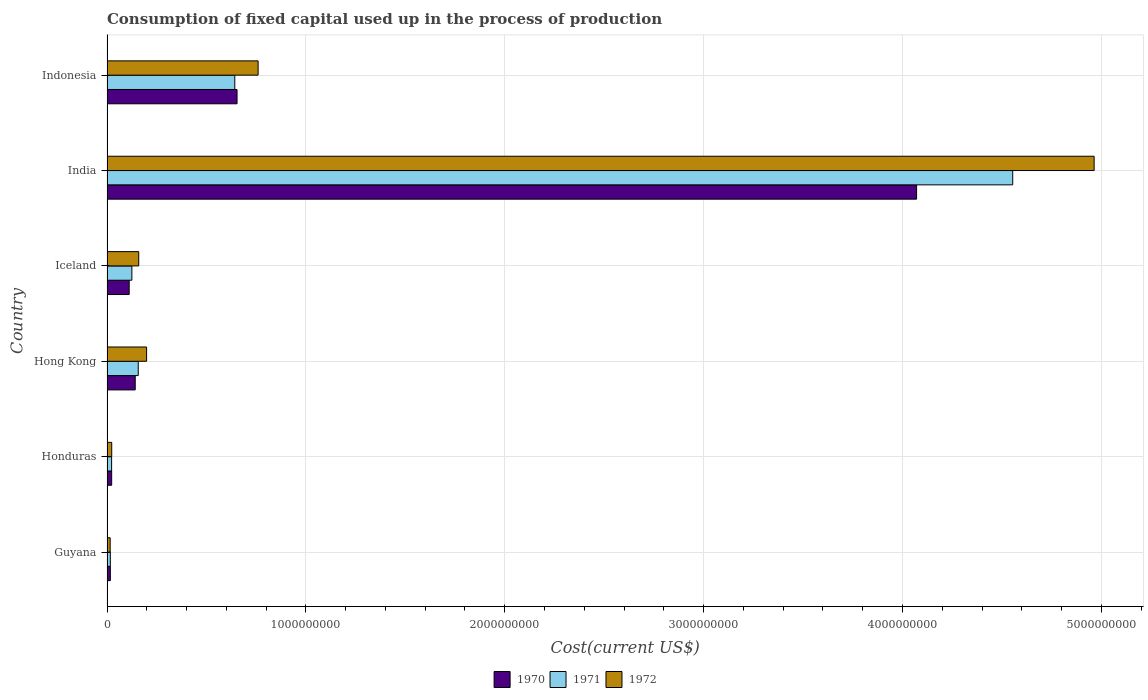How many different coloured bars are there?
Make the answer very short. 3. How many groups of bars are there?
Offer a terse response. 6. Are the number of bars per tick equal to the number of legend labels?
Your answer should be very brief. Yes. How many bars are there on the 2nd tick from the top?
Keep it short and to the point. 3. How many bars are there on the 5th tick from the bottom?
Provide a succinct answer. 3. What is the label of the 6th group of bars from the top?
Make the answer very short. Guyana. What is the amount consumed in the process of production in 1970 in Iceland?
Your response must be concise. 1.12e+08. Across all countries, what is the maximum amount consumed in the process of production in 1970?
Provide a succinct answer. 4.07e+09. Across all countries, what is the minimum amount consumed in the process of production in 1971?
Offer a terse response. 1.67e+07. In which country was the amount consumed in the process of production in 1972 minimum?
Offer a terse response. Guyana. What is the total amount consumed in the process of production in 1972 in the graph?
Give a very brief answer. 6.12e+09. What is the difference between the amount consumed in the process of production in 1972 in Hong Kong and that in Indonesia?
Make the answer very short. -5.61e+08. What is the difference between the amount consumed in the process of production in 1970 in Honduras and the amount consumed in the process of production in 1971 in Indonesia?
Keep it short and to the point. -6.19e+08. What is the average amount consumed in the process of production in 1971 per country?
Make the answer very short. 9.20e+08. What is the difference between the amount consumed in the process of production in 1970 and amount consumed in the process of production in 1972 in Honduras?
Offer a terse response. -2.98e+05. What is the ratio of the amount consumed in the process of production in 1972 in Hong Kong to that in Indonesia?
Offer a terse response. 0.26. Is the amount consumed in the process of production in 1970 in Guyana less than that in Hong Kong?
Keep it short and to the point. Yes. What is the difference between the highest and the second highest amount consumed in the process of production in 1970?
Keep it short and to the point. 3.42e+09. What is the difference between the highest and the lowest amount consumed in the process of production in 1972?
Ensure brevity in your answer.  4.95e+09. What does the 3rd bar from the top in Indonesia represents?
Your answer should be very brief. 1970. What does the 1st bar from the bottom in India represents?
Your response must be concise. 1970. How many bars are there?
Your response must be concise. 18. Are all the bars in the graph horizontal?
Offer a very short reply. Yes. What is the difference between two consecutive major ticks on the X-axis?
Your answer should be compact. 1.00e+09. Does the graph contain any zero values?
Offer a terse response. No. Does the graph contain grids?
Offer a very short reply. Yes. How many legend labels are there?
Make the answer very short. 3. How are the legend labels stacked?
Offer a very short reply. Horizontal. What is the title of the graph?
Keep it short and to the point. Consumption of fixed capital used up in the process of production. Does "1960" appear as one of the legend labels in the graph?
Keep it short and to the point. No. What is the label or title of the X-axis?
Provide a succinct answer. Cost(current US$). What is the label or title of the Y-axis?
Keep it short and to the point. Country. What is the Cost(current US$) in 1970 in Guyana?
Offer a terse response. 1.69e+07. What is the Cost(current US$) of 1971 in Guyana?
Provide a short and direct response. 1.67e+07. What is the Cost(current US$) in 1972 in Guyana?
Offer a very short reply. 1.59e+07. What is the Cost(current US$) of 1970 in Honduras?
Offer a very short reply. 2.34e+07. What is the Cost(current US$) in 1971 in Honduras?
Keep it short and to the point. 2.32e+07. What is the Cost(current US$) of 1972 in Honduras?
Give a very brief answer. 2.37e+07. What is the Cost(current US$) in 1970 in Hong Kong?
Offer a terse response. 1.42e+08. What is the Cost(current US$) in 1971 in Hong Kong?
Provide a succinct answer. 1.57e+08. What is the Cost(current US$) of 1972 in Hong Kong?
Your answer should be compact. 1.99e+08. What is the Cost(current US$) of 1970 in Iceland?
Ensure brevity in your answer.  1.12e+08. What is the Cost(current US$) of 1971 in Iceland?
Offer a very short reply. 1.25e+08. What is the Cost(current US$) in 1972 in Iceland?
Ensure brevity in your answer.  1.60e+08. What is the Cost(current US$) in 1970 in India?
Offer a terse response. 4.07e+09. What is the Cost(current US$) of 1971 in India?
Offer a terse response. 4.55e+09. What is the Cost(current US$) of 1972 in India?
Give a very brief answer. 4.96e+09. What is the Cost(current US$) in 1970 in Indonesia?
Your response must be concise. 6.54e+08. What is the Cost(current US$) of 1971 in Indonesia?
Keep it short and to the point. 6.43e+08. What is the Cost(current US$) in 1972 in Indonesia?
Your answer should be compact. 7.60e+08. Across all countries, what is the maximum Cost(current US$) in 1970?
Provide a short and direct response. 4.07e+09. Across all countries, what is the maximum Cost(current US$) in 1971?
Keep it short and to the point. 4.55e+09. Across all countries, what is the maximum Cost(current US$) in 1972?
Make the answer very short. 4.96e+09. Across all countries, what is the minimum Cost(current US$) in 1970?
Give a very brief answer. 1.69e+07. Across all countries, what is the minimum Cost(current US$) of 1971?
Make the answer very short. 1.67e+07. Across all countries, what is the minimum Cost(current US$) of 1972?
Offer a very short reply. 1.59e+07. What is the total Cost(current US$) in 1970 in the graph?
Provide a short and direct response. 5.02e+09. What is the total Cost(current US$) of 1971 in the graph?
Make the answer very short. 5.52e+09. What is the total Cost(current US$) in 1972 in the graph?
Offer a very short reply. 6.12e+09. What is the difference between the Cost(current US$) in 1970 in Guyana and that in Honduras?
Provide a short and direct response. -6.54e+06. What is the difference between the Cost(current US$) of 1971 in Guyana and that in Honduras?
Ensure brevity in your answer.  -6.46e+06. What is the difference between the Cost(current US$) in 1972 in Guyana and that in Honduras?
Your answer should be very brief. -7.83e+06. What is the difference between the Cost(current US$) in 1970 in Guyana and that in Hong Kong?
Your response must be concise. -1.25e+08. What is the difference between the Cost(current US$) in 1971 in Guyana and that in Hong Kong?
Offer a terse response. -1.40e+08. What is the difference between the Cost(current US$) in 1972 in Guyana and that in Hong Kong?
Your answer should be compact. -1.83e+08. What is the difference between the Cost(current US$) in 1970 in Guyana and that in Iceland?
Make the answer very short. -9.46e+07. What is the difference between the Cost(current US$) of 1971 in Guyana and that in Iceland?
Your answer should be very brief. -1.08e+08. What is the difference between the Cost(current US$) of 1972 in Guyana and that in Iceland?
Make the answer very short. -1.44e+08. What is the difference between the Cost(current US$) in 1970 in Guyana and that in India?
Your answer should be compact. -4.05e+09. What is the difference between the Cost(current US$) in 1971 in Guyana and that in India?
Provide a succinct answer. -4.54e+09. What is the difference between the Cost(current US$) in 1972 in Guyana and that in India?
Your answer should be very brief. -4.95e+09. What is the difference between the Cost(current US$) of 1970 in Guyana and that in Indonesia?
Ensure brevity in your answer.  -6.37e+08. What is the difference between the Cost(current US$) of 1971 in Guyana and that in Indonesia?
Offer a terse response. -6.26e+08. What is the difference between the Cost(current US$) in 1972 in Guyana and that in Indonesia?
Your response must be concise. -7.44e+08. What is the difference between the Cost(current US$) of 1970 in Honduras and that in Hong Kong?
Make the answer very short. -1.18e+08. What is the difference between the Cost(current US$) of 1971 in Honduras and that in Hong Kong?
Make the answer very short. -1.34e+08. What is the difference between the Cost(current US$) of 1972 in Honduras and that in Hong Kong?
Provide a succinct answer. -1.75e+08. What is the difference between the Cost(current US$) in 1970 in Honduras and that in Iceland?
Offer a terse response. -8.81e+07. What is the difference between the Cost(current US$) in 1971 in Honduras and that in Iceland?
Ensure brevity in your answer.  -1.02e+08. What is the difference between the Cost(current US$) in 1972 in Honduras and that in Iceland?
Offer a terse response. -1.36e+08. What is the difference between the Cost(current US$) in 1970 in Honduras and that in India?
Offer a very short reply. -4.05e+09. What is the difference between the Cost(current US$) of 1971 in Honduras and that in India?
Your answer should be compact. -4.53e+09. What is the difference between the Cost(current US$) in 1972 in Honduras and that in India?
Offer a terse response. -4.94e+09. What is the difference between the Cost(current US$) of 1970 in Honduras and that in Indonesia?
Your response must be concise. -6.30e+08. What is the difference between the Cost(current US$) in 1971 in Honduras and that in Indonesia?
Your answer should be very brief. -6.19e+08. What is the difference between the Cost(current US$) of 1972 in Honduras and that in Indonesia?
Offer a terse response. -7.36e+08. What is the difference between the Cost(current US$) in 1970 in Hong Kong and that in Iceland?
Make the answer very short. 3.03e+07. What is the difference between the Cost(current US$) in 1971 in Hong Kong and that in Iceland?
Make the answer very short. 3.21e+07. What is the difference between the Cost(current US$) in 1972 in Hong Kong and that in Iceland?
Ensure brevity in your answer.  3.95e+07. What is the difference between the Cost(current US$) of 1970 in Hong Kong and that in India?
Provide a short and direct response. -3.93e+09. What is the difference between the Cost(current US$) in 1971 in Hong Kong and that in India?
Make the answer very short. -4.40e+09. What is the difference between the Cost(current US$) in 1972 in Hong Kong and that in India?
Provide a succinct answer. -4.76e+09. What is the difference between the Cost(current US$) in 1970 in Hong Kong and that in Indonesia?
Your response must be concise. -5.12e+08. What is the difference between the Cost(current US$) in 1971 in Hong Kong and that in Indonesia?
Keep it short and to the point. -4.86e+08. What is the difference between the Cost(current US$) of 1972 in Hong Kong and that in Indonesia?
Give a very brief answer. -5.61e+08. What is the difference between the Cost(current US$) in 1970 in Iceland and that in India?
Give a very brief answer. -3.96e+09. What is the difference between the Cost(current US$) in 1971 in Iceland and that in India?
Ensure brevity in your answer.  -4.43e+09. What is the difference between the Cost(current US$) in 1972 in Iceland and that in India?
Provide a succinct answer. -4.80e+09. What is the difference between the Cost(current US$) of 1970 in Iceland and that in Indonesia?
Ensure brevity in your answer.  -5.42e+08. What is the difference between the Cost(current US$) in 1971 in Iceland and that in Indonesia?
Your answer should be compact. -5.18e+08. What is the difference between the Cost(current US$) of 1972 in Iceland and that in Indonesia?
Offer a terse response. -6.00e+08. What is the difference between the Cost(current US$) in 1970 in India and that in Indonesia?
Make the answer very short. 3.42e+09. What is the difference between the Cost(current US$) in 1971 in India and that in Indonesia?
Offer a very short reply. 3.91e+09. What is the difference between the Cost(current US$) in 1972 in India and that in Indonesia?
Offer a terse response. 4.20e+09. What is the difference between the Cost(current US$) in 1970 in Guyana and the Cost(current US$) in 1971 in Honduras?
Offer a very short reply. -6.26e+06. What is the difference between the Cost(current US$) of 1970 in Guyana and the Cost(current US$) of 1972 in Honduras?
Offer a very short reply. -6.83e+06. What is the difference between the Cost(current US$) of 1971 in Guyana and the Cost(current US$) of 1972 in Honduras?
Your response must be concise. -7.03e+06. What is the difference between the Cost(current US$) of 1970 in Guyana and the Cost(current US$) of 1971 in Hong Kong?
Offer a terse response. -1.40e+08. What is the difference between the Cost(current US$) in 1970 in Guyana and the Cost(current US$) in 1972 in Hong Kong?
Your answer should be very brief. -1.82e+08. What is the difference between the Cost(current US$) in 1971 in Guyana and the Cost(current US$) in 1972 in Hong Kong?
Your response must be concise. -1.82e+08. What is the difference between the Cost(current US$) in 1970 in Guyana and the Cost(current US$) in 1971 in Iceland?
Your response must be concise. -1.08e+08. What is the difference between the Cost(current US$) of 1970 in Guyana and the Cost(current US$) of 1972 in Iceland?
Your answer should be very brief. -1.43e+08. What is the difference between the Cost(current US$) in 1971 in Guyana and the Cost(current US$) in 1972 in Iceland?
Provide a short and direct response. -1.43e+08. What is the difference between the Cost(current US$) in 1970 in Guyana and the Cost(current US$) in 1971 in India?
Keep it short and to the point. -4.54e+09. What is the difference between the Cost(current US$) of 1970 in Guyana and the Cost(current US$) of 1972 in India?
Make the answer very short. -4.95e+09. What is the difference between the Cost(current US$) of 1971 in Guyana and the Cost(current US$) of 1972 in India?
Keep it short and to the point. -4.95e+09. What is the difference between the Cost(current US$) in 1970 in Guyana and the Cost(current US$) in 1971 in Indonesia?
Your answer should be compact. -6.26e+08. What is the difference between the Cost(current US$) of 1970 in Guyana and the Cost(current US$) of 1972 in Indonesia?
Make the answer very short. -7.43e+08. What is the difference between the Cost(current US$) in 1971 in Guyana and the Cost(current US$) in 1972 in Indonesia?
Give a very brief answer. -7.43e+08. What is the difference between the Cost(current US$) of 1970 in Honduras and the Cost(current US$) of 1971 in Hong Kong?
Your answer should be compact. -1.34e+08. What is the difference between the Cost(current US$) in 1970 in Honduras and the Cost(current US$) in 1972 in Hong Kong?
Offer a terse response. -1.76e+08. What is the difference between the Cost(current US$) in 1971 in Honduras and the Cost(current US$) in 1972 in Hong Kong?
Your answer should be compact. -1.76e+08. What is the difference between the Cost(current US$) of 1970 in Honduras and the Cost(current US$) of 1971 in Iceland?
Provide a short and direct response. -1.02e+08. What is the difference between the Cost(current US$) in 1970 in Honduras and the Cost(current US$) in 1972 in Iceland?
Your answer should be compact. -1.36e+08. What is the difference between the Cost(current US$) in 1971 in Honduras and the Cost(current US$) in 1972 in Iceland?
Ensure brevity in your answer.  -1.36e+08. What is the difference between the Cost(current US$) of 1970 in Honduras and the Cost(current US$) of 1971 in India?
Your answer should be very brief. -4.53e+09. What is the difference between the Cost(current US$) of 1970 in Honduras and the Cost(current US$) of 1972 in India?
Your answer should be compact. -4.94e+09. What is the difference between the Cost(current US$) in 1971 in Honduras and the Cost(current US$) in 1972 in India?
Provide a succinct answer. -4.94e+09. What is the difference between the Cost(current US$) of 1970 in Honduras and the Cost(current US$) of 1971 in Indonesia?
Your answer should be very brief. -6.19e+08. What is the difference between the Cost(current US$) in 1970 in Honduras and the Cost(current US$) in 1972 in Indonesia?
Give a very brief answer. -7.36e+08. What is the difference between the Cost(current US$) of 1971 in Honduras and the Cost(current US$) of 1972 in Indonesia?
Provide a short and direct response. -7.37e+08. What is the difference between the Cost(current US$) of 1970 in Hong Kong and the Cost(current US$) of 1971 in Iceland?
Your response must be concise. 1.69e+07. What is the difference between the Cost(current US$) in 1970 in Hong Kong and the Cost(current US$) in 1972 in Iceland?
Offer a terse response. -1.77e+07. What is the difference between the Cost(current US$) in 1971 in Hong Kong and the Cost(current US$) in 1972 in Iceland?
Provide a short and direct response. -2.45e+06. What is the difference between the Cost(current US$) in 1970 in Hong Kong and the Cost(current US$) in 1971 in India?
Provide a succinct answer. -4.41e+09. What is the difference between the Cost(current US$) in 1970 in Hong Kong and the Cost(current US$) in 1972 in India?
Your response must be concise. -4.82e+09. What is the difference between the Cost(current US$) in 1971 in Hong Kong and the Cost(current US$) in 1972 in India?
Ensure brevity in your answer.  -4.81e+09. What is the difference between the Cost(current US$) in 1970 in Hong Kong and the Cost(current US$) in 1971 in Indonesia?
Provide a succinct answer. -5.01e+08. What is the difference between the Cost(current US$) in 1970 in Hong Kong and the Cost(current US$) in 1972 in Indonesia?
Your answer should be very brief. -6.18e+08. What is the difference between the Cost(current US$) in 1971 in Hong Kong and the Cost(current US$) in 1972 in Indonesia?
Your response must be concise. -6.03e+08. What is the difference between the Cost(current US$) in 1970 in Iceland and the Cost(current US$) in 1971 in India?
Offer a very short reply. -4.44e+09. What is the difference between the Cost(current US$) in 1970 in Iceland and the Cost(current US$) in 1972 in India?
Keep it short and to the point. -4.85e+09. What is the difference between the Cost(current US$) in 1971 in Iceland and the Cost(current US$) in 1972 in India?
Your response must be concise. -4.84e+09. What is the difference between the Cost(current US$) of 1970 in Iceland and the Cost(current US$) of 1971 in Indonesia?
Keep it short and to the point. -5.31e+08. What is the difference between the Cost(current US$) in 1970 in Iceland and the Cost(current US$) in 1972 in Indonesia?
Keep it short and to the point. -6.48e+08. What is the difference between the Cost(current US$) of 1971 in Iceland and the Cost(current US$) of 1972 in Indonesia?
Ensure brevity in your answer.  -6.35e+08. What is the difference between the Cost(current US$) in 1970 in India and the Cost(current US$) in 1971 in Indonesia?
Provide a short and direct response. 3.43e+09. What is the difference between the Cost(current US$) in 1970 in India and the Cost(current US$) in 1972 in Indonesia?
Ensure brevity in your answer.  3.31e+09. What is the difference between the Cost(current US$) in 1971 in India and the Cost(current US$) in 1972 in Indonesia?
Offer a very short reply. 3.79e+09. What is the average Cost(current US$) of 1970 per country?
Give a very brief answer. 8.36e+08. What is the average Cost(current US$) in 1971 per country?
Keep it short and to the point. 9.20e+08. What is the average Cost(current US$) of 1972 per country?
Offer a very short reply. 1.02e+09. What is the difference between the Cost(current US$) in 1970 and Cost(current US$) in 1972 in Guyana?
Your response must be concise. 9.95e+05. What is the difference between the Cost(current US$) in 1971 and Cost(current US$) in 1972 in Guyana?
Offer a very short reply. 7.95e+05. What is the difference between the Cost(current US$) in 1970 and Cost(current US$) in 1971 in Honduras?
Give a very brief answer. 2.75e+05. What is the difference between the Cost(current US$) of 1970 and Cost(current US$) of 1972 in Honduras?
Your answer should be compact. -2.98e+05. What is the difference between the Cost(current US$) of 1971 and Cost(current US$) of 1972 in Honduras?
Give a very brief answer. -5.73e+05. What is the difference between the Cost(current US$) of 1970 and Cost(current US$) of 1971 in Hong Kong?
Keep it short and to the point. -1.52e+07. What is the difference between the Cost(current US$) of 1970 and Cost(current US$) of 1972 in Hong Kong?
Your answer should be compact. -5.72e+07. What is the difference between the Cost(current US$) of 1971 and Cost(current US$) of 1972 in Hong Kong?
Make the answer very short. -4.20e+07. What is the difference between the Cost(current US$) of 1970 and Cost(current US$) of 1971 in Iceland?
Provide a succinct answer. -1.34e+07. What is the difference between the Cost(current US$) of 1970 and Cost(current US$) of 1972 in Iceland?
Offer a terse response. -4.80e+07. What is the difference between the Cost(current US$) in 1971 and Cost(current US$) in 1972 in Iceland?
Your answer should be compact. -3.46e+07. What is the difference between the Cost(current US$) in 1970 and Cost(current US$) in 1971 in India?
Your response must be concise. -4.83e+08. What is the difference between the Cost(current US$) in 1970 and Cost(current US$) in 1972 in India?
Give a very brief answer. -8.93e+08. What is the difference between the Cost(current US$) of 1971 and Cost(current US$) of 1972 in India?
Give a very brief answer. -4.09e+08. What is the difference between the Cost(current US$) in 1970 and Cost(current US$) in 1971 in Indonesia?
Your answer should be compact. 1.13e+07. What is the difference between the Cost(current US$) of 1970 and Cost(current US$) of 1972 in Indonesia?
Your response must be concise. -1.06e+08. What is the difference between the Cost(current US$) in 1971 and Cost(current US$) in 1972 in Indonesia?
Make the answer very short. -1.17e+08. What is the ratio of the Cost(current US$) in 1970 in Guyana to that in Honduras?
Provide a short and direct response. 0.72. What is the ratio of the Cost(current US$) of 1971 in Guyana to that in Honduras?
Offer a terse response. 0.72. What is the ratio of the Cost(current US$) of 1972 in Guyana to that in Honduras?
Provide a short and direct response. 0.67. What is the ratio of the Cost(current US$) of 1970 in Guyana to that in Hong Kong?
Keep it short and to the point. 0.12. What is the ratio of the Cost(current US$) in 1971 in Guyana to that in Hong Kong?
Your answer should be compact. 0.11. What is the ratio of the Cost(current US$) of 1972 in Guyana to that in Hong Kong?
Ensure brevity in your answer.  0.08. What is the ratio of the Cost(current US$) of 1970 in Guyana to that in Iceland?
Make the answer very short. 0.15. What is the ratio of the Cost(current US$) of 1971 in Guyana to that in Iceland?
Keep it short and to the point. 0.13. What is the ratio of the Cost(current US$) of 1972 in Guyana to that in Iceland?
Offer a terse response. 0.1. What is the ratio of the Cost(current US$) of 1970 in Guyana to that in India?
Your response must be concise. 0. What is the ratio of the Cost(current US$) of 1971 in Guyana to that in India?
Make the answer very short. 0. What is the ratio of the Cost(current US$) in 1972 in Guyana to that in India?
Offer a very short reply. 0. What is the ratio of the Cost(current US$) of 1970 in Guyana to that in Indonesia?
Ensure brevity in your answer.  0.03. What is the ratio of the Cost(current US$) in 1971 in Guyana to that in Indonesia?
Provide a succinct answer. 0.03. What is the ratio of the Cost(current US$) in 1972 in Guyana to that in Indonesia?
Ensure brevity in your answer.  0.02. What is the ratio of the Cost(current US$) of 1970 in Honduras to that in Hong Kong?
Provide a short and direct response. 0.17. What is the ratio of the Cost(current US$) of 1971 in Honduras to that in Hong Kong?
Offer a terse response. 0.15. What is the ratio of the Cost(current US$) in 1972 in Honduras to that in Hong Kong?
Ensure brevity in your answer.  0.12. What is the ratio of the Cost(current US$) of 1970 in Honduras to that in Iceland?
Ensure brevity in your answer.  0.21. What is the ratio of the Cost(current US$) of 1971 in Honduras to that in Iceland?
Your response must be concise. 0.19. What is the ratio of the Cost(current US$) in 1972 in Honduras to that in Iceland?
Offer a terse response. 0.15. What is the ratio of the Cost(current US$) in 1970 in Honduras to that in India?
Ensure brevity in your answer.  0.01. What is the ratio of the Cost(current US$) of 1971 in Honduras to that in India?
Offer a terse response. 0.01. What is the ratio of the Cost(current US$) in 1972 in Honduras to that in India?
Ensure brevity in your answer.  0. What is the ratio of the Cost(current US$) in 1970 in Honduras to that in Indonesia?
Make the answer very short. 0.04. What is the ratio of the Cost(current US$) of 1971 in Honduras to that in Indonesia?
Make the answer very short. 0.04. What is the ratio of the Cost(current US$) in 1972 in Honduras to that in Indonesia?
Provide a succinct answer. 0.03. What is the ratio of the Cost(current US$) of 1970 in Hong Kong to that in Iceland?
Give a very brief answer. 1.27. What is the ratio of the Cost(current US$) in 1971 in Hong Kong to that in Iceland?
Provide a succinct answer. 1.26. What is the ratio of the Cost(current US$) in 1972 in Hong Kong to that in Iceland?
Give a very brief answer. 1.25. What is the ratio of the Cost(current US$) in 1970 in Hong Kong to that in India?
Provide a short and direct response. 0.03. What is the ratio of the Cost(current US$) of 1971 in Hong Kong to that in India?
Give a very brief answer. 0.03. What is the ratio of the Cost(current US$) in 1972 in Hong Kong to that in India?
Give a very brief answer. 0.04. What is the ratio of the Cost(current US$) in 1970 in Hong Kong to that in Indonesia?
Your answer should be compact. 0.22. What is the ratio of the Cost(current US$) of 1971 in Hong Kong to that in Indonesia?
Your response must be concise. 0.24. What is the ratio of the Cost(current US$) in 1972 in Hong Kong to that in Indonesia?
Your answer should be compact. 0.26. What is the ratio of the Cost(current US$) in 1970 in Iceland to that in India?
Your response must be concise. 0.03. What is the ratio of the Cost(current US$) in 1971 in Iceland to that in India?
Your answer should be very brief. 0.03. What is the ratio of the Cost(current US$) of 1972 in Iceland to that in India?
Offer a terse response. 0.03. What is the ratio of the Cost(current US$) in 1970 in Iceland to that in Indonesia?
Offer a terse response. 0.17. What is the ratio of the Cost(current US$) in 1971 in Iceland to that in Indonesia?
Provide a short and direct response. 0.19. What is the ratio of the Cost(current US$) in 1972 in Iceland to that in Indonesia?
Keep it short and to the point. 0.21. What is the ratio of the Cost(current US$) in 1970 in India to that in Indonesia?
Provide a succinct answer. 6.23. What is the ratio of the Cost(current US$) in 1971 in India to that in Indonesia?
Provide a succinct answer. 7.09. What is the ratio of the Cost(current US$) in 1972 in India to that in Indonesia?
Keep it short and to the point. 6.53. What is the difference between the highest and the second highest Cost(current US$) of 1970?
Provide a short and direct response. 3.42e+09. What is the difference between the highest and the second highest Cost(current US$) of 1971?
Offer a terse response. 3.91e+09. What is the difference between the highest and the second highest Cost(current US$) in 1972?
Give a very brief answer. 4.20e+09. What is the difference between the highest and the lowest Cost(current US$) in 1970?
Make the answer very short. 4.05e+09. What is the difference between the highest and the lowest Cost(current US$) of 1971?
Keep it short and to the point. 4.54e+09. What is the difference between the highest and the lowest Cost(current US$) in 1972?
Offer a terse response. 4.95e+09. 